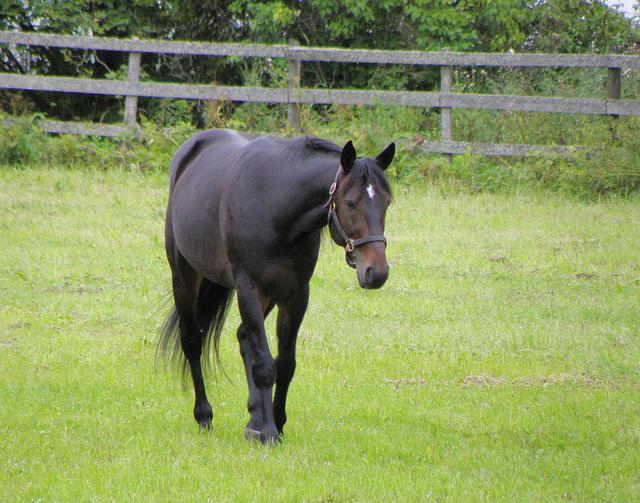How many white cows are there?
Give a very brief answer. 0. 